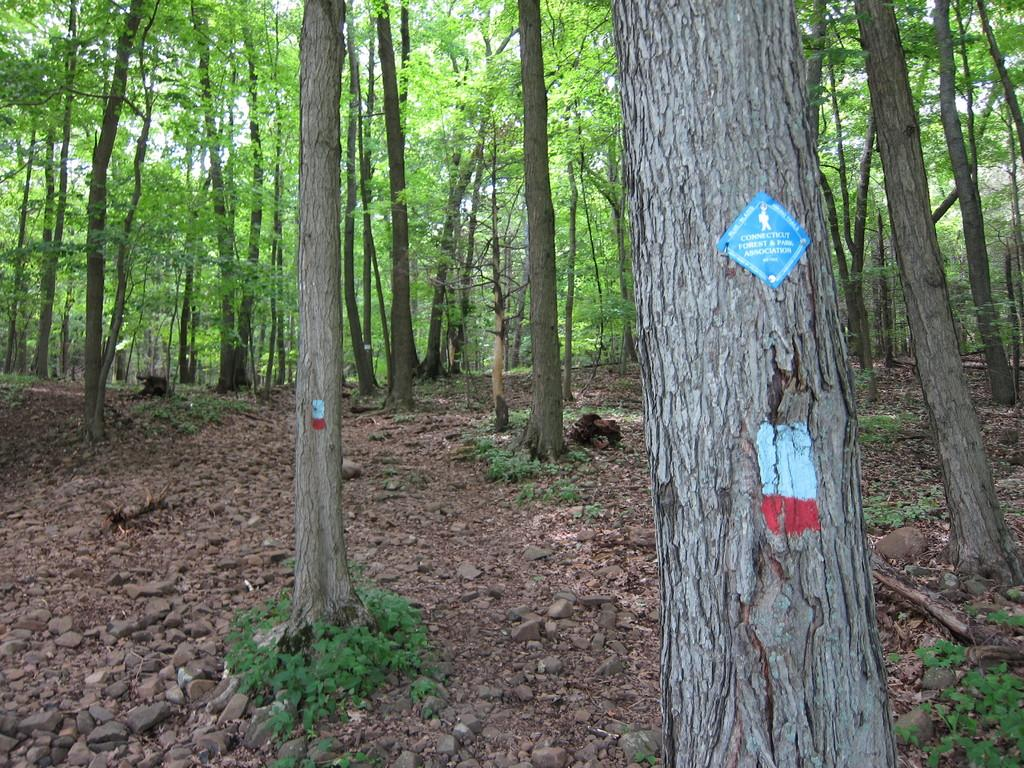What type of vegetation can be seen in the image? There are plants and trees in the image. Where are the plants and trees located? The plants and trees are on the ground in the image. Can you describe any additional features on the trees? Yes, there is a sticker present on a tree in the image. How does the person in the image push the crib? There is no person or crib present in the image; it only features plants and trees with a sticker on one of the trees. 